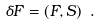Convert formula to latex. <formula><loc_0><loc_0><loc_500><loc_500>\delta F = ( F , S ) \ .</formula> 